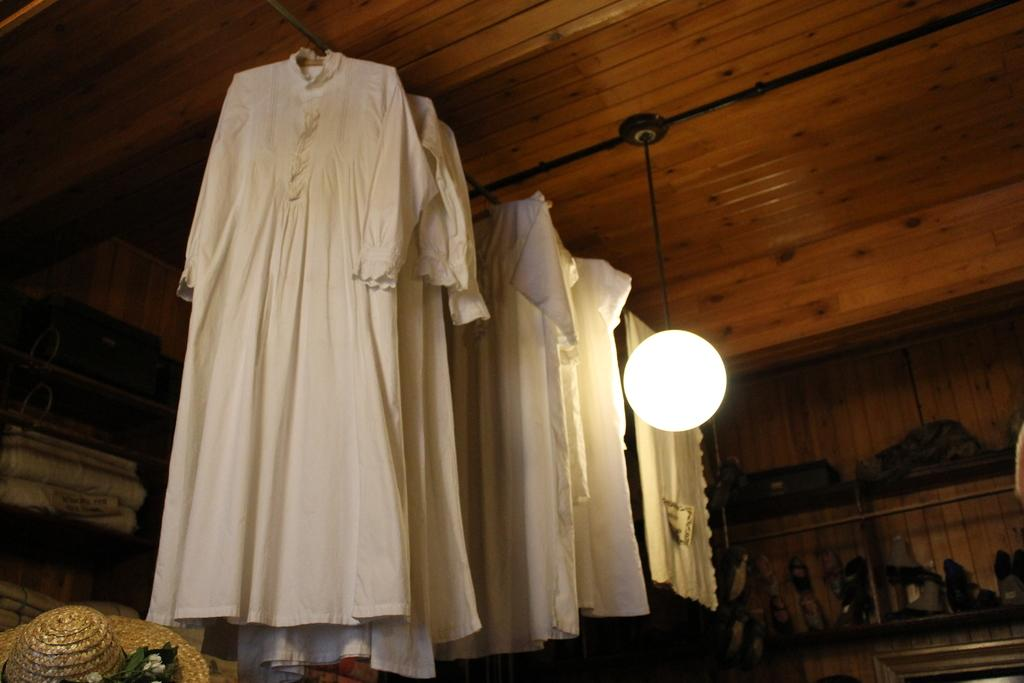What is hanging from the ceiling in the image? There are clothes attached to the ceiling in the image. What source of illumination is present in the image? There is a light in the image. What type of headwear can be seen in the image? A hat is visible in the image. Can you describe any other objects present in the image? There are other objects present in the image, but their specific details are not mentioned in the provided facts. How many snails are crawling on the hat in the image? There are no snails present in the image; only clothes, a light, and a hat are mentioned. What type of prose is written on the clothes hanging from the ceiling? There is no prose written on the clothes hanging from the ceiling in the image. 